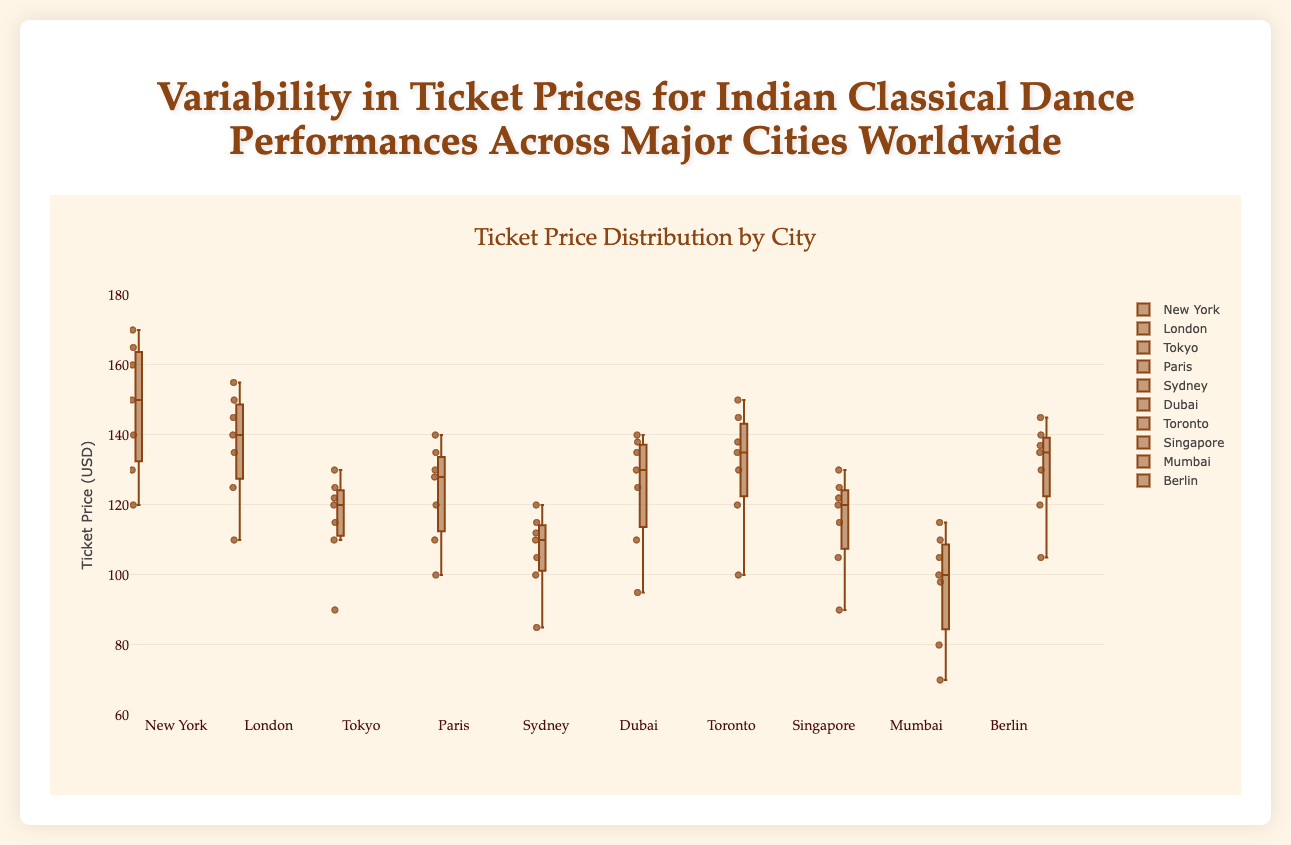What is the median ticket price for performances in New York? The median is the middle value in an ordered list of numbers. In New York, the ticket prices are 120, 130, 140, 150, 160, 165, 170. The middle value here is 150.
Answer: 150 What city has the highest median ticket price? Comparing the median ticket prices from each city. The highest median comes from New York (150).
Answer: New York Which city exhibits the greatest variability in ticket prices? Variability can be assessed by observing the box plot’s interquartile range (IQR) and the distance between the maximum and minimum values. New York shows the widest range in its box and whiskers.
Answer: New York What's the range of ticket prices for performances in Mumbai? The range is calculated by subtracting the smallest value from the largest value. In Mumbai, the ticket prices range from 70 to 115, so the range is 115 - 70 = 45.
Answer: 45 Among the cities listed, which has the lowest median ticket price? Observing the medians depicted in the box plots, the city with the lowest median is Mumbai.
Answer: Mumbai How does the interquartile range (IQR) of Sydney compare to that of Tokyo? The IQR is the difference between the third quartile (Q3) and the first quartile (Q1). For Sydney, the IQR is from 105 to 120, so 120 - 105 = 15. For Tokyo, it’s from 115 to 125, so 125 - 115 = 10. Sydney has a larger IQR than Tokyo.
Answer: Sydney has a larger IQR Which city's ticket prices appear most consistent (least variable)? The city with the smallest range or the smallest IQR shows the least variability. Tokyo appears the most consistent based on its smaller IQR and range.
Answer: Tokyo Do any cities share the same median ticket price? If so, which ones? Comparing the medians across cities, Tokyo and Singapore both have a median ticket price of 120.
Answer: Tokyo and Singapore Which city has the highest outlier ticket price, and what is that price? Observing individual points outside of the whiskers, New York has the highest outlier price at 170.
Answer: New York, 170 